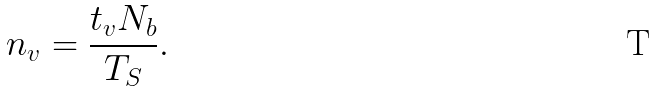<formula> <loc_0><loc_0><loc_500><loc_500>n _ { v } = \frac { t _ { v } N _ { b } } { T _ { S } } .</formula> 